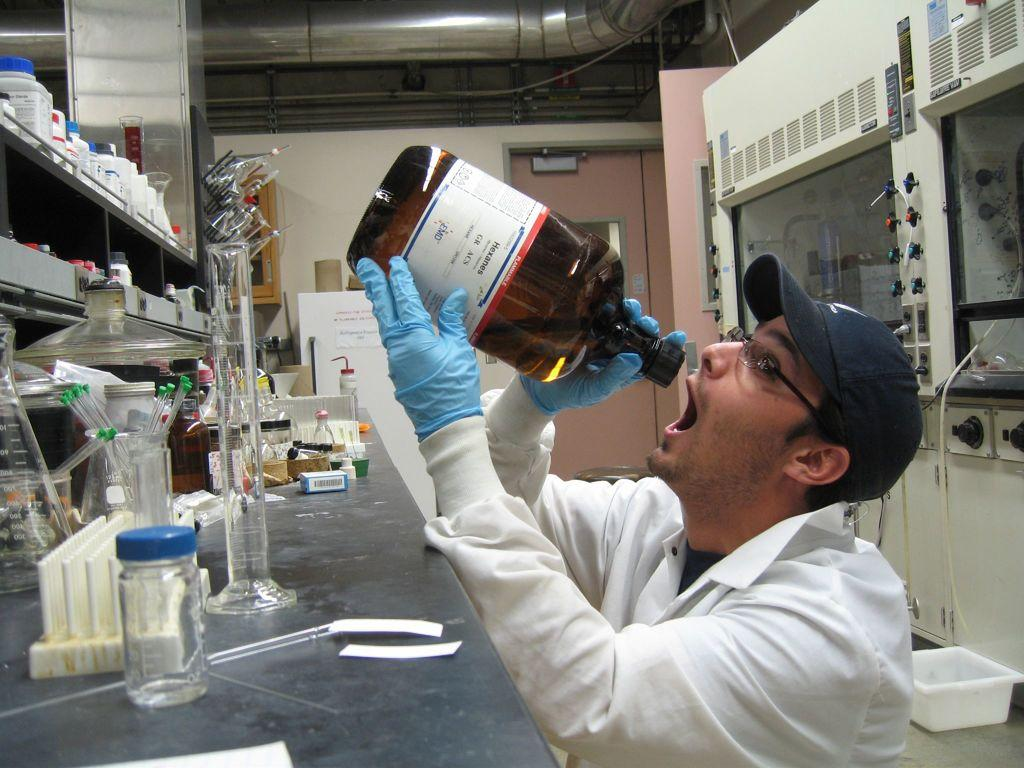What is the man in the image holding in his hand? The man is holding a bottle in his hand. Can you describe the bottle in the image? There is a bottle in the image. What else can be seen in the image besides the man and the bottle? There is a flask, a tray rack, a pipe, and a device in the background of the image. What type of button is being pressed by the man in the image? There is no button present in the image, and the man is not shown pressing any button. What is the air quality like in the image? The provided facts do not give any information about the air quality in the image. 